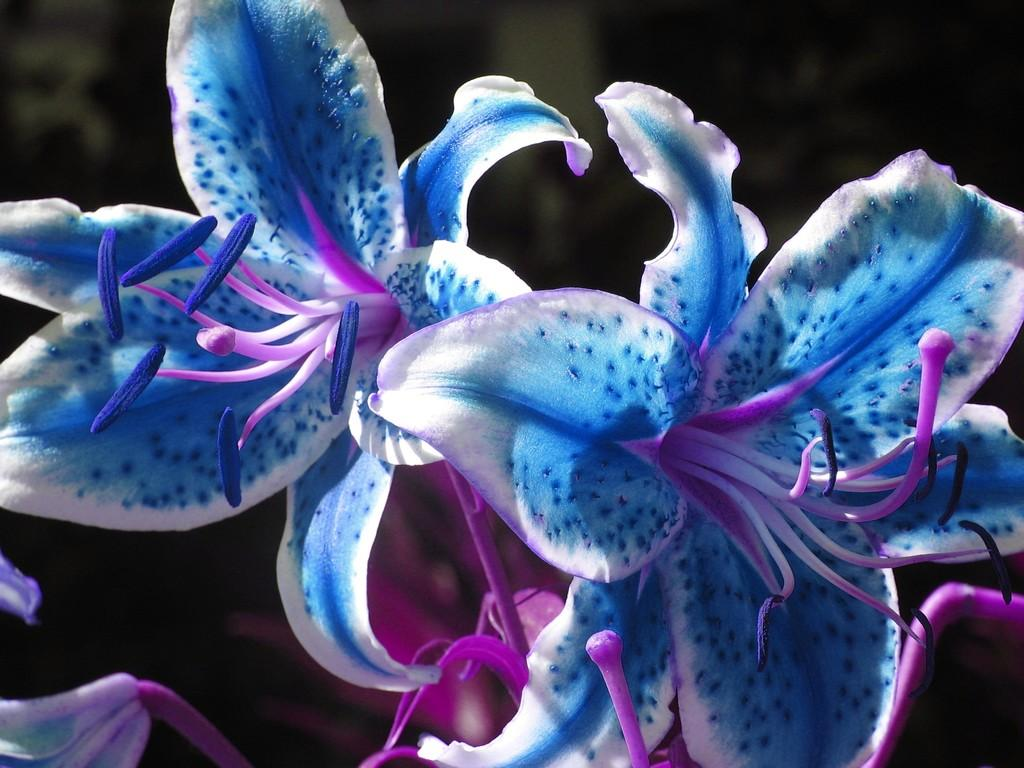What type of flowers can be seen in the image? There are blue color flowers in the image. What is the color of the background in the image? The background of the image is dark. What type of road can be seen in the image? There is no road present in the image; it features blue color flowers and a dark background. What scientific principle is demonstrated in the image? The image does not depict any scientific principle; it simply shows blue color flowers against a dark background. 